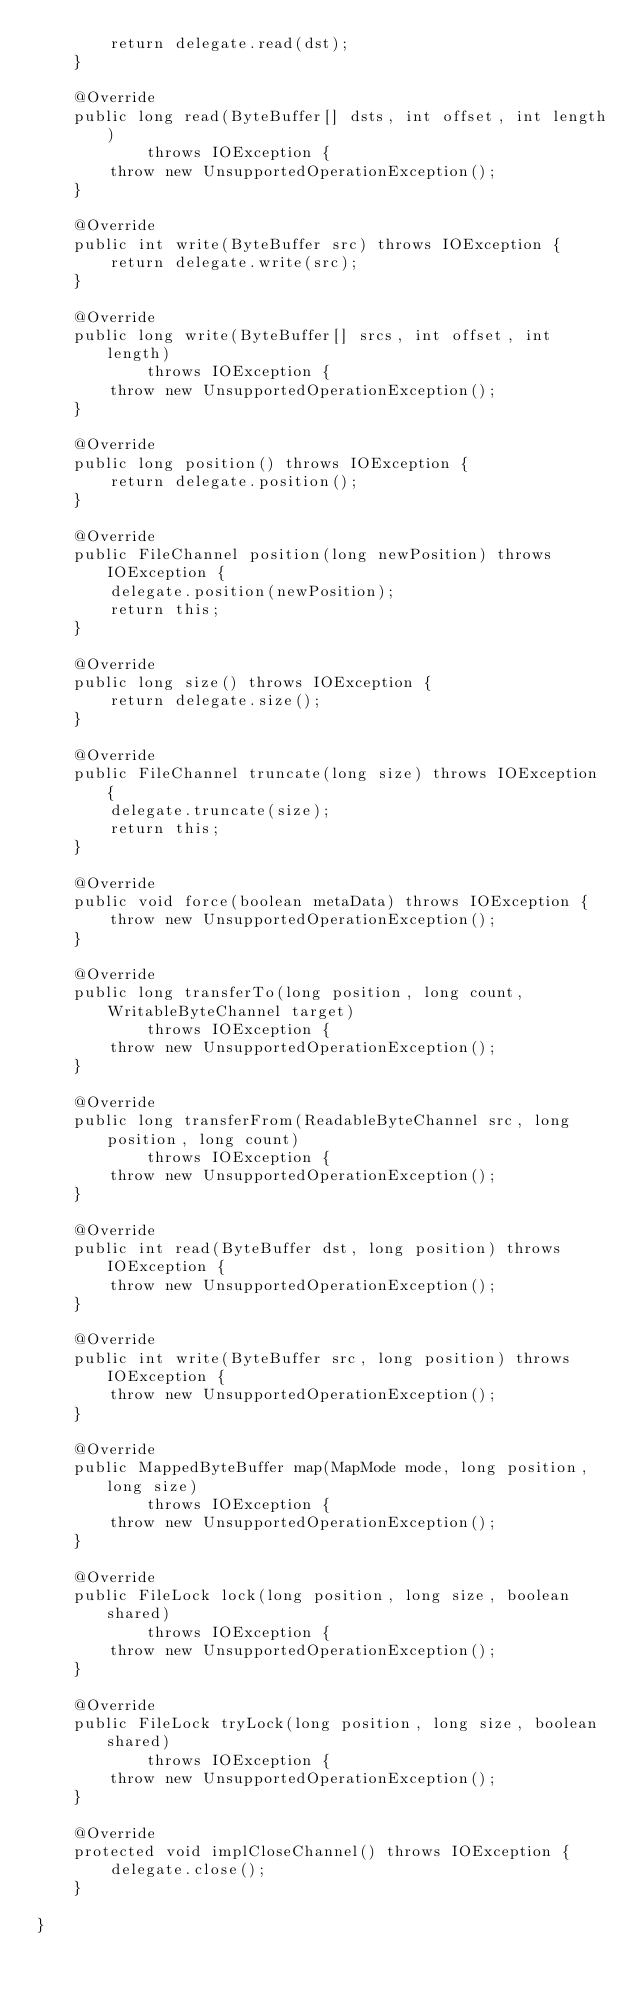Convert code to text. <code><loc_0><loc_0><loc_500><loc_500><_Java_>        return delegate.read(dst);
    }

    @Override
    public long read(ByteBuffer[] dsts, int offset, int length)
            throws IOException {
        throw new UnsupportedOperationException();
    }

    @Override
    public int write(ByteBuffer src) throws IOException {
        return delegate.write(src);
    }

    @Override
    public long write(ByteBuffer[] srcs, int offset, int length)
            throws IOException {
        throw new UnsupportedOperationException();
    }

    @Override
    public long position() throws IOException {
        return delegate.position();
    }

    @Override
    public FileChannel position(long newPosition) throws IOException {
        delegate.position(newPosition);
        return this;
    }

    @Override
    public long size() throws IOException {
        return delegate.size();
    }

    @Override
    public FileChannel truncate(long size) throws IOException {
        delegate.truncate(size);
        return this;
    }

    @Override
    public void force(boolean metaData) throws IOException {
        throw new UnsupportedOperationException();
    }

    @Override
    public long transferTo(long position, long count, WritableByteChannel target)
            throws IOException {
        throw new UnsupportedOperationException();
    }

    @Override
    public long transferFrom(ReadableByteChannel src, long position, long count)
            throws IOException {
        throw new UnsupportedOperationException();
    }

    @Override
    public int read(ByteBuffer dst, long position) throws IOException {
        throw new UnsupportedOperationException();
    }

    @Override
    public int write(ByteBuffer src, long position) throws IOException {
        throw new UnsupportedOperationException();
    }

    @Override
    public MappedByteBuffer map(MapMode mode, long position, long size)
            throws IOException {
        throw new UnsupportedOperationException();
    }

    @Override
    public FileLock lock(long position, long size, boolean shared)
            throws IOException {
        throw new UnsupportedOperationException();
    }

    @Override
    public FileLock tryLock(long position, long size, boolean shared)
            throws IOException {
        throw new UnsupportedOperationException();
    }

    @Override
    protected void implCloseChannel() throws IOException {
        delegate.close();
    }

}
</code> 